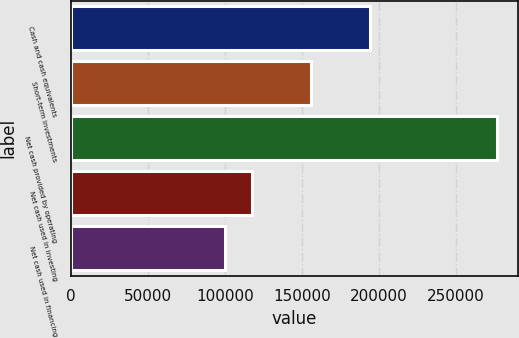Convert chart. <chart><loc_0><loc_0><loc_500><loc_500><bar_chart><fcel>Cash and cash equivalents<fcel>Short-term investments<fcel>Net cash provided by operating<fcel>Net cash used in investing<fcel>Net cash used in financing<nl><fcel>194499<fcel>155888<fcel>276401<fcel>117681<fcel>100045<nl></chart> 